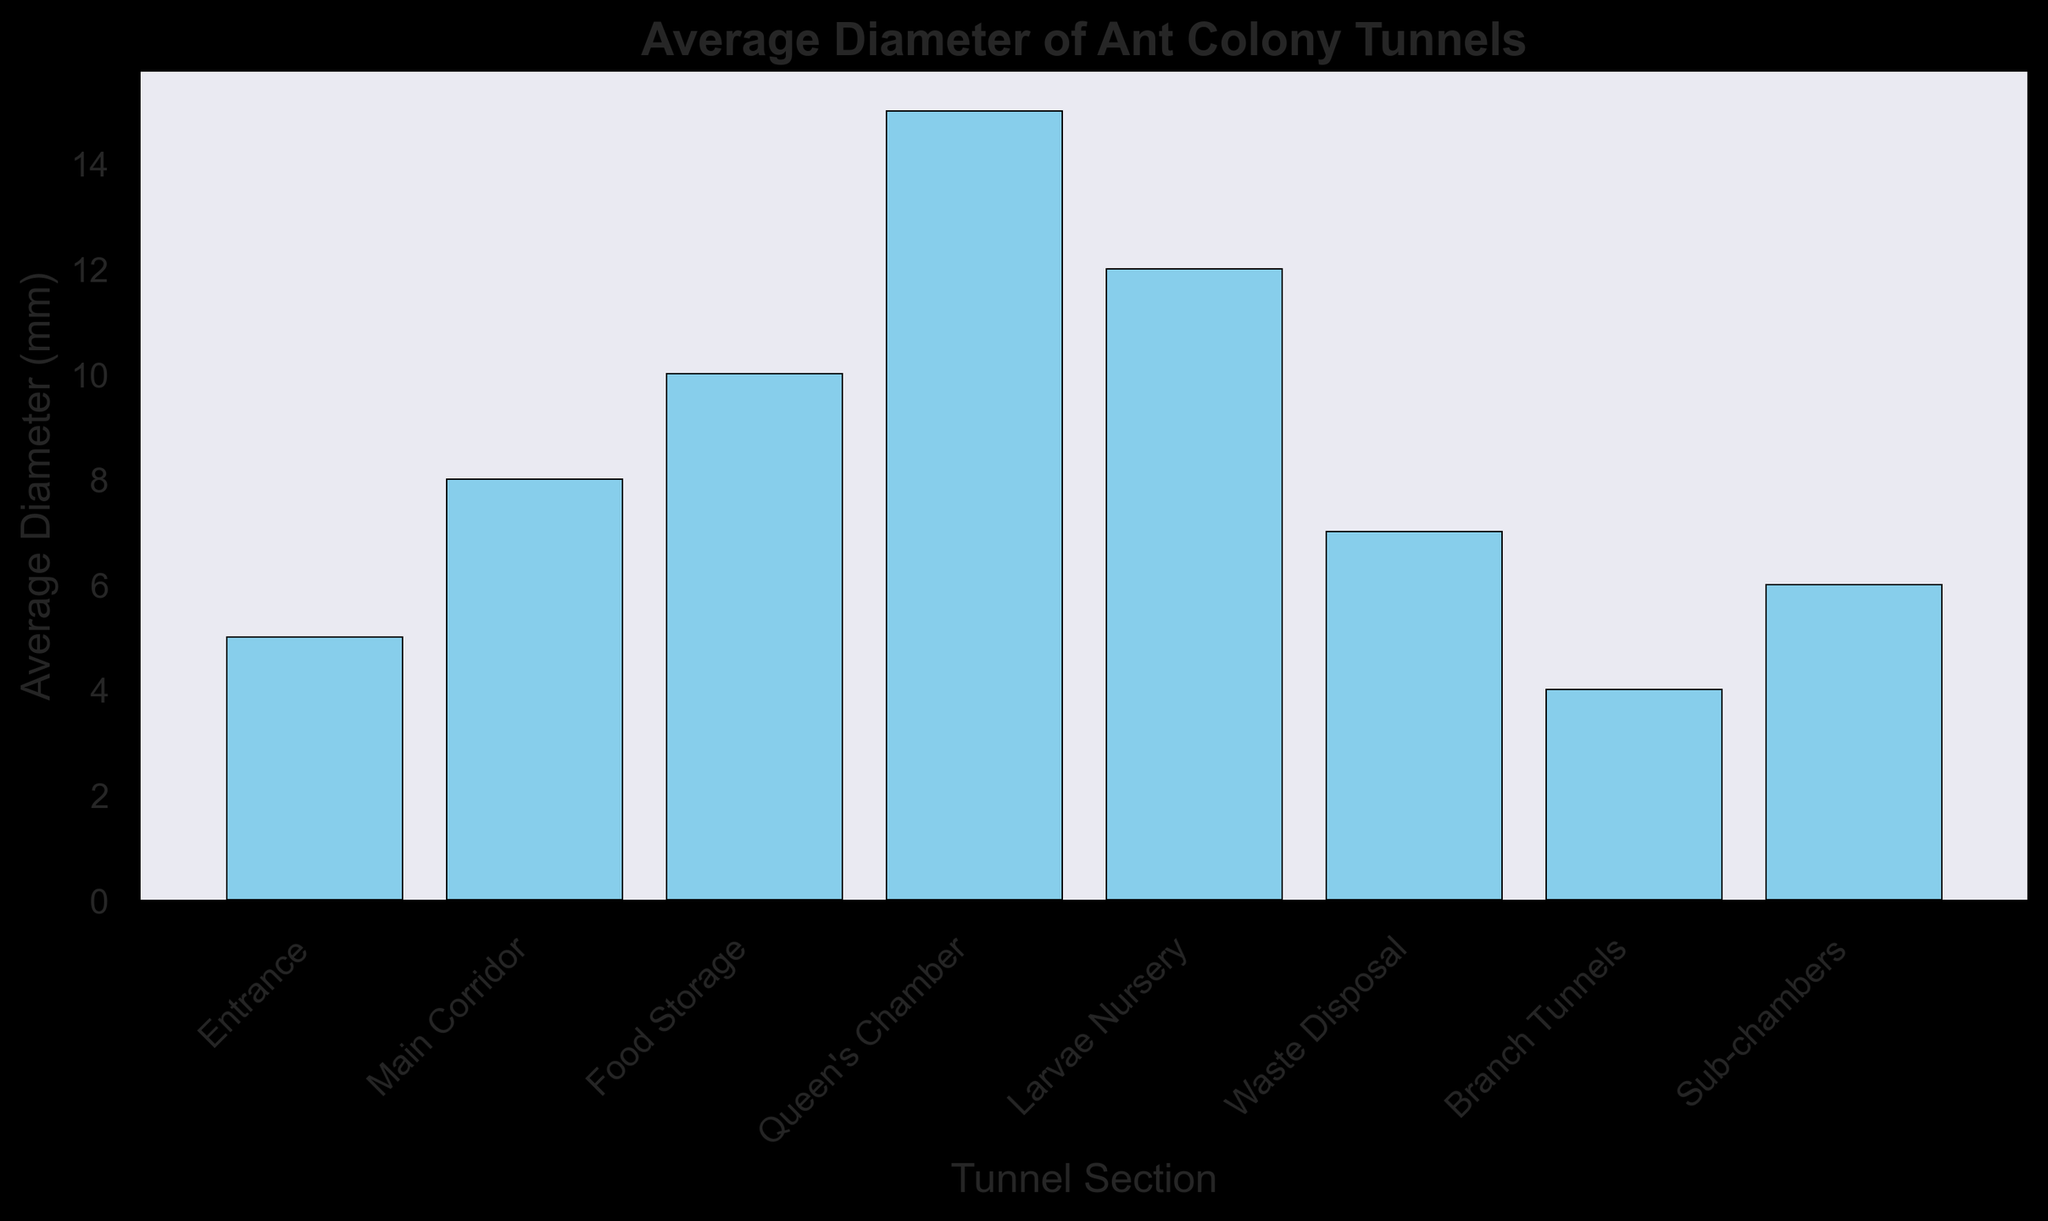Which tunnel section has the largest average diameter? The bar representing "Queen's Chamber" has the greatest height among all the sections, indicating the largest average diameter.
Answer: Queen's Chamber How much bigger is the average diameter of the Queen's Chamber compared to the Entrance? The average diameter of the Queen's Chamber is 15 mm, while the Entrance is 5 mm. The difference is calculated as 15 mm - 5 mm.
Answer: 10 mm Which tunnel sections have average diameters less than the Main Corridor? The Main Corridor has an average diameter of 8 mm. The sections with shorter bars (average diameters less than 8 mm) are the Entrance, Waste Disposal, Branch Tunnels, and Sub-chambers.
Answer: Entrance, Waste Disposal, Branch Tunnels, Sub-chambers What is the sum of average diameters of the Food Storage and Larvae Nursery sections? The average diameter of Food Storage is 10 mm and Larvae Nursery is 12 mm, so the sum is 10 mm + 12 mm.
Answer: 22 mm Rank the tunnel sections in decreasing order of their average diameters. The sections can be ranked by the height of the bars from tallest to shortest: Queen's Chamber (15 mm), Larvae Nursery (12 mm), Food Storage (10 mm), Main Corridor (8 mm), Waste Disposal (7 mm), Sub-chambers (6 mm), Entrance (5 mm), Branch Tunnels (4 mm).
Answer: Queen's Chamber, Larvae Nursery, Food Storage, Main Corridor, Waste Disposal, Sub-chambers, Entrance, Branch Tunnels How many tunnel sections have an average diameter greater than 6 mm? Count the sections with bars taller than the bar for 6 mm. They are Main Corridor, Food Storage, Queen's Chamber, Larvae Nursery, and Waste Disposal. There are 5 sections in total.
Answer: 5 What is the average diameter of all the tunnel sections combined? Sum the average diameters: 5 mm + 8 mm + 10 mm + 15 mm + 12 mm + 7 mm + 4 mm + 6 mm = 67 mm, then divide by the number of sections (8).
Answer: 8.375 mm Which section’s bar is closest in height to the Waste Disposal section’s bar? Waste Disposal has an average diameter of 7 mm. Sub-chambers have an average diameter of 6 mm, which is the closest value.
Answer: Sub-chambers 